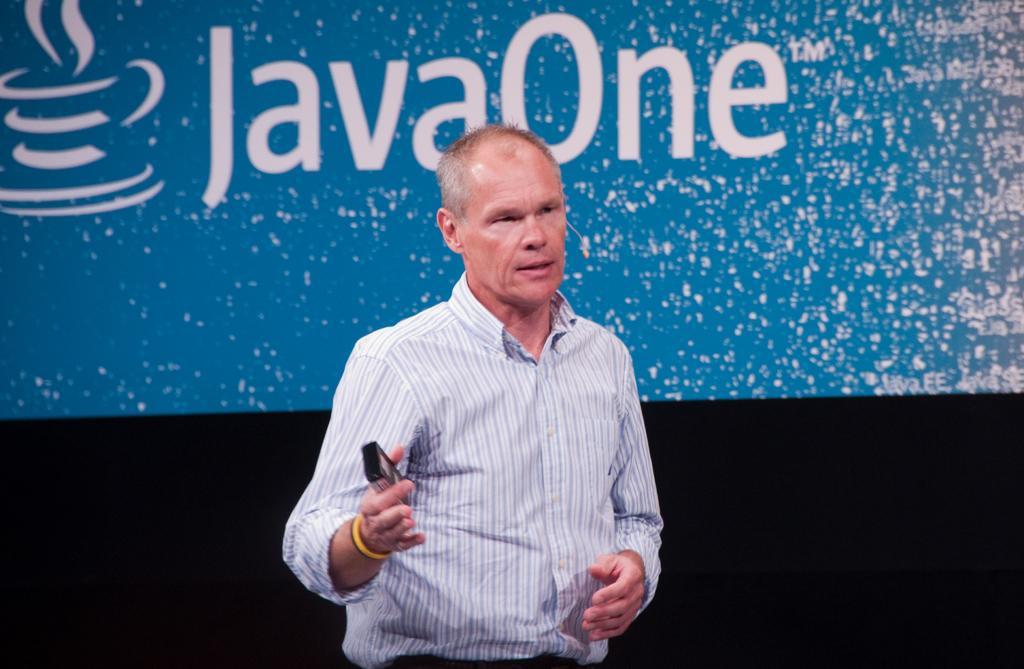Can you describe this image briefly? Here I can see a man wearing a shirt, holding an object in the hand, standing and speaking by looking at the right side. At the back of him there is a screen on which I can see some text. 